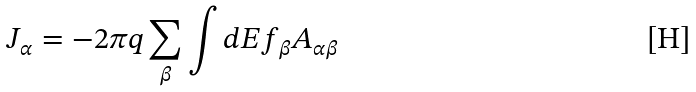Convert formula to latex. <formula><loc_0><loc_0><loc_500><loc_500>J _ { \alpha } = - 2 \pi q \sum _ { \beta } \int d E f _ { \beta } A _ { \alpha \beta }</formula> 